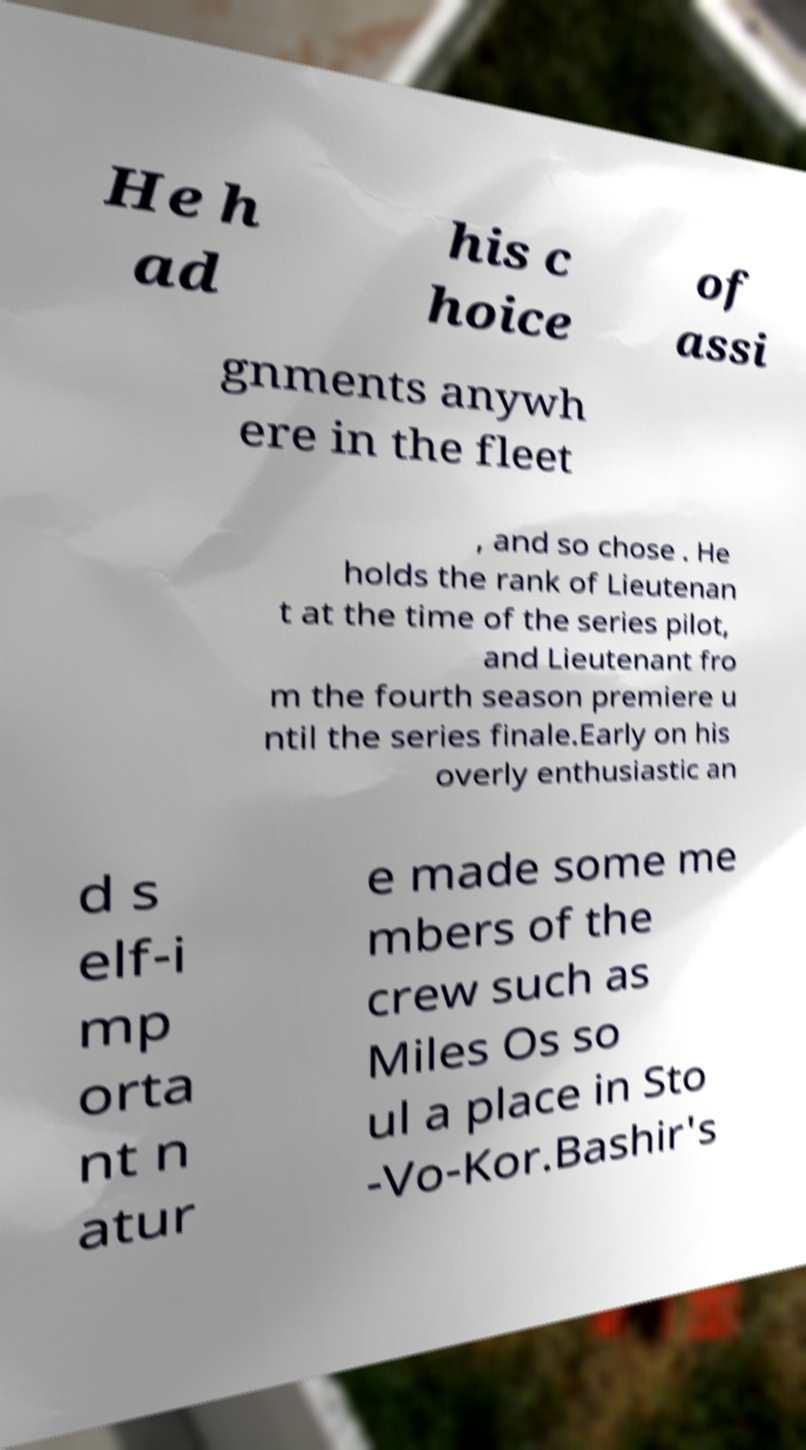Can you accurately transcribe the text from the provided image for me? He h ad his c hoice of assi gnments anywh ere in the fleet , and so chose . He holds the rank of Lieutenan t at the time of the series pilot, and Lieutenant fro m the fourth season premiere u ntil the series finale.Early on his overly enthusiastic an d s elf-i mp orta nt n atur e made some me mbers of the crew such as Miles Os so ul a place in Sto -Vo-Kor.Bashir's 